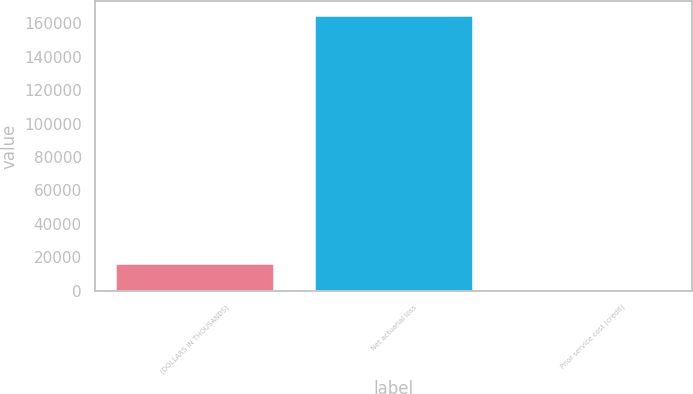<chart> <loc_0><loc_0><loc_500><loc_500><bar_chart><fcel>(DOLLARS IN THOUSANDS)<fcel>Net actuarial loss<fcel>Prior service cost (credit)<nl><fcel>16692<fcel>165093<fcel>203<nl></chart> 